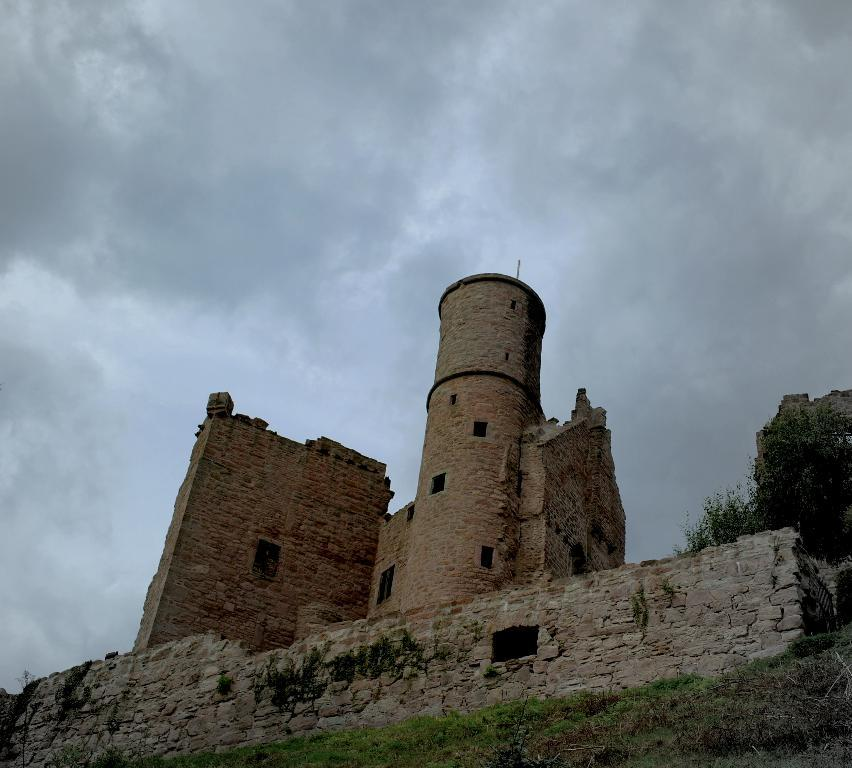What type of vegetation is in the foreground of the image? There is grass in the foreground of the image. What type of structure is in the middle of the image? There is a stone castle in the middle of the image. What other object is in the middle of the image? There is a tree in the middle of the image. What is visible at the top of the image? There are clouds visible at the top of the image. What type of chalk is being used to draw on the castle walls in the image? There is no chalk or drawing activity present in the image; it features a stone castle, grass, a tree, and clouds. How does the quilt keep the tree warm in the image? There is no quilt present in the image, and trees do not require warmth from quilts. 